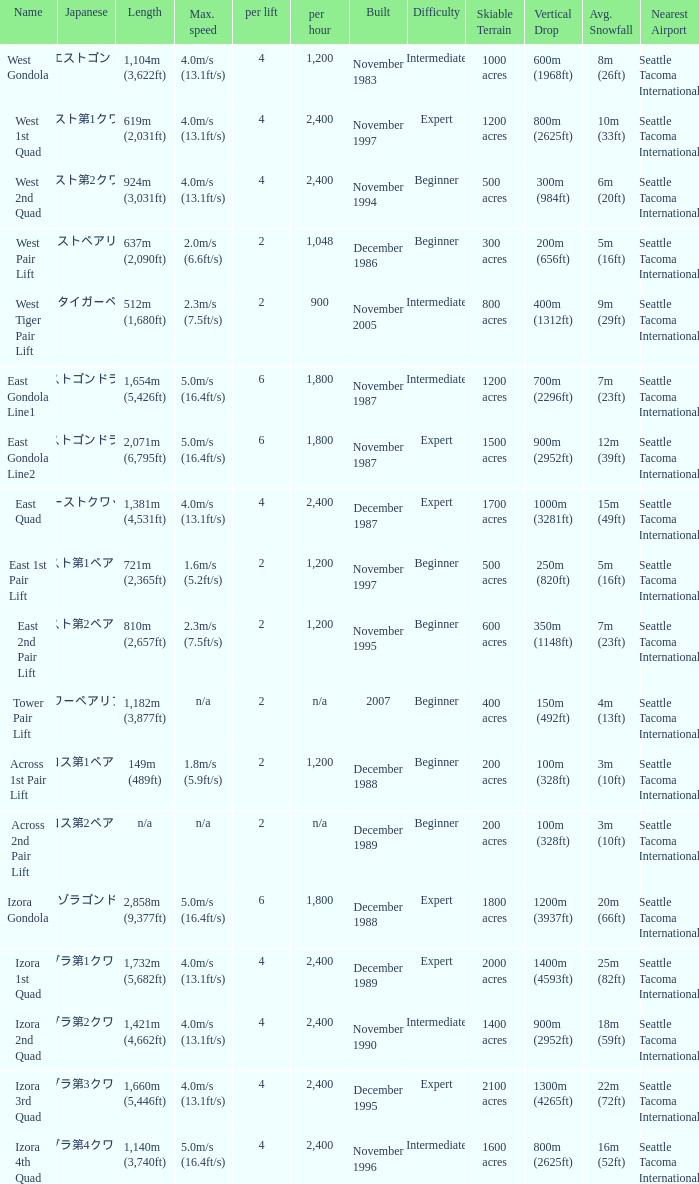How heavy is the  maximum 6.0. 